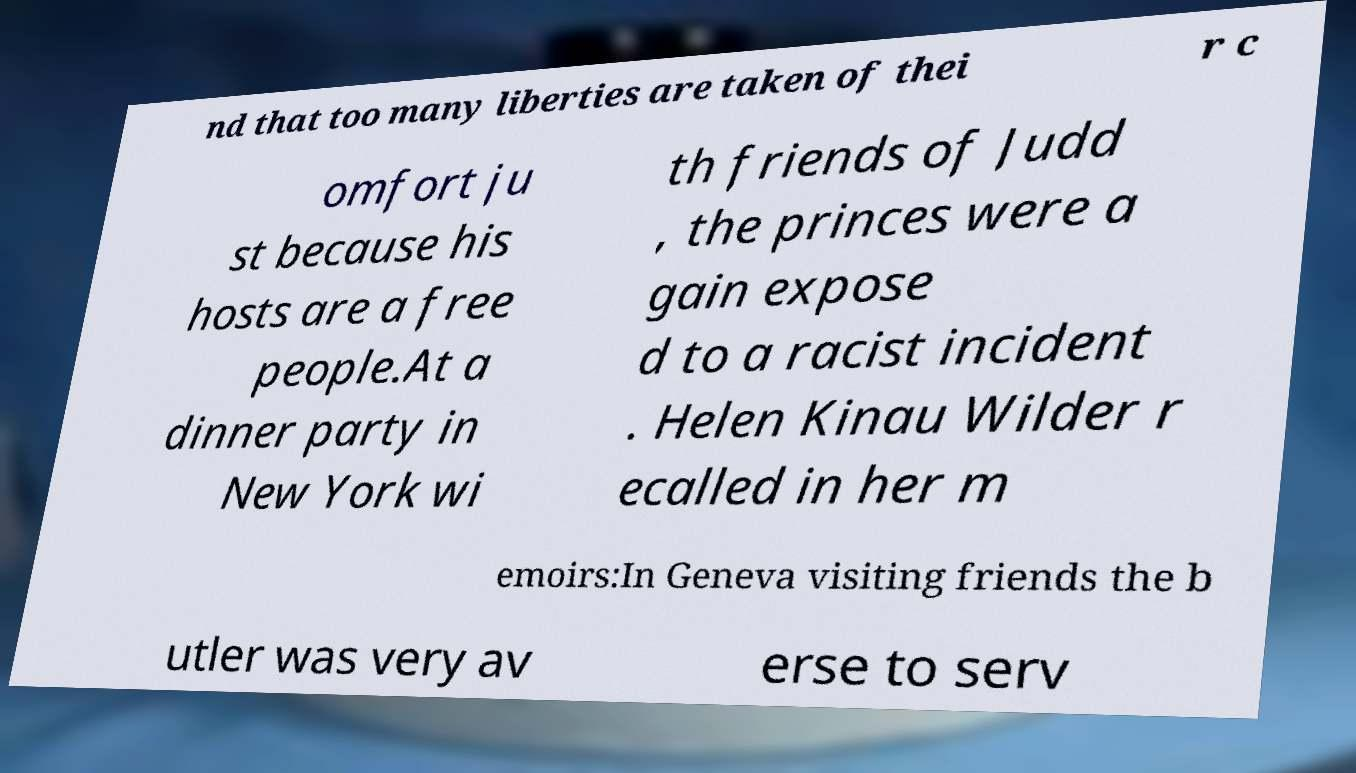Please identify and transcribe the text found in this image. nd that too many liberties are taken of thei r c omfort ju st because his hosts are a free people.At a dinner party in New York wi th friends of Judd , the princes were a gain expose d to a racist incident . Helen Kinau Wilder r ecalled in her m emoirs:In Geneva visiting friends the b utler was very av erse to serv 